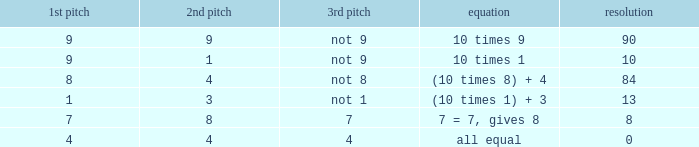If the equation is all equal, what is the 3rd throw? 4.0. 